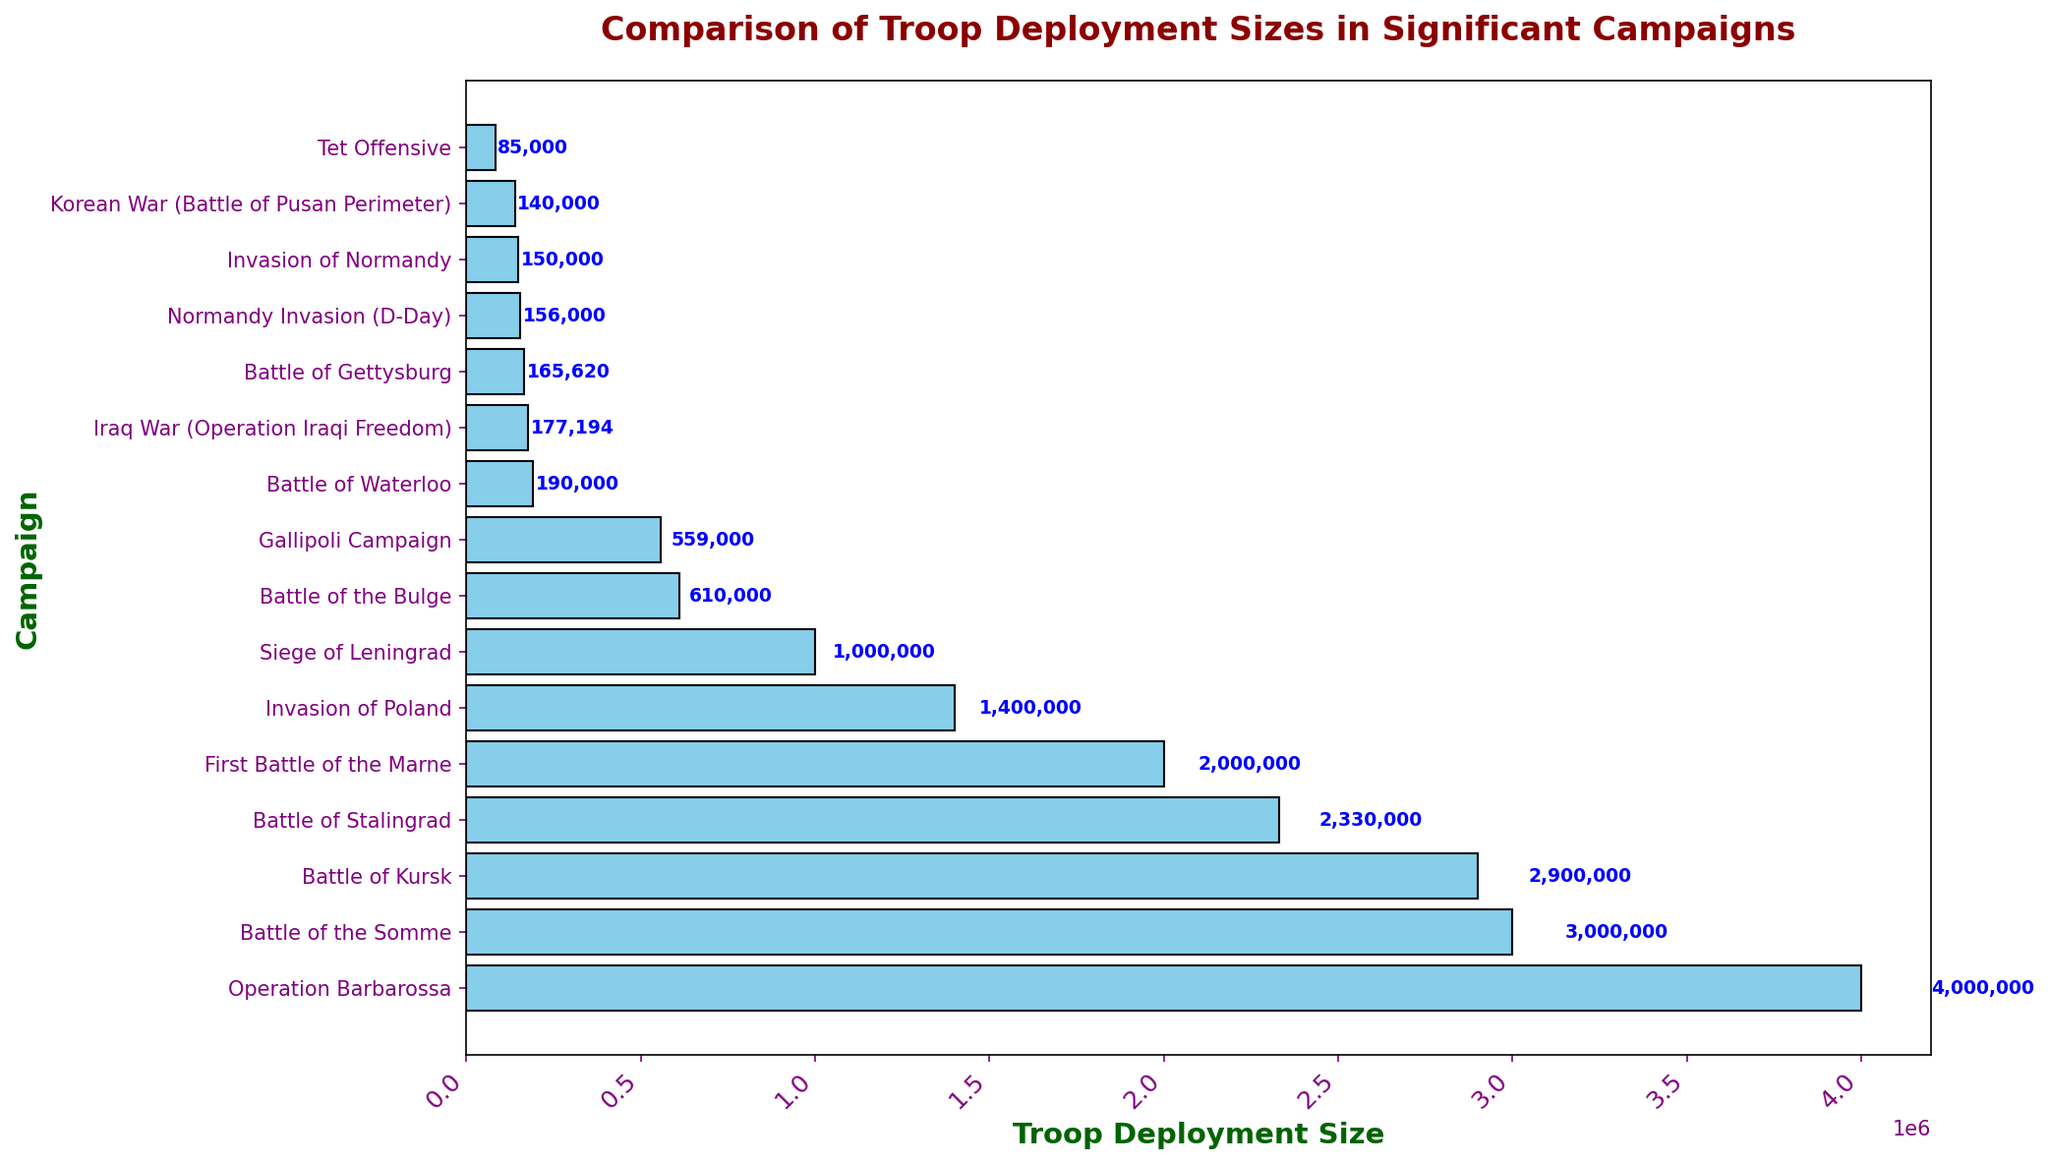What's the campaign with the highest troop deployment size? To understand which campaign had the highest troop deployment size, we identify the bar with the greatest length, representing the largest value. The 'Operation Barbarossa' bar is the highest.
Answer: Operation Barbarossa Which campaign had a larger troop deployment, the Battle of Stalingrad or the Battle of the Bulge? By comparing the lengths of the bars for the Battle of Stalingrad and the Battle of the Bulge, it is evident that the Battle of Stalingrad has a longer bar, indicating a larger troop deployment.
Answer: Battle of Stalingrad How does the troop deployment size for the Invasion of Poland compare to that of the Normandy Invasion (D-Day)? Observing the bar lengths for both the Invasion of Poland and the Normandy Invasion (D-Day), the Invasion of Poland has a significantly longer bar, indicating a larger troop deployment size than Normandy Invasion (D-Day).
Answer: Invasion of Poland What is the total troop deployment size for the First Battle of the Marne and the Battle of the Somme combined? To find the total, add the troop deployment sizes for the First Battle of the Marne (2,000,000) and the Battle of the Somme (3,000,000). The calculation is 2,000,000 + 3,000,000 = 5,000,000.
Answer: 5,000,000 Which campaign between the Gallipoli Campaign and the Invasion of Normandy had fewer troops deployed? Comparing the bars of the Gallipoli Campaign and the Invasion of Normandy, the Invasion of Normandy has a shorter bar, indicating fewer troops were deployed compared to the Gallipoli Campaign.
Answer: Invasion of Normandy What’s the average troop deployment size for the campaigns in the 20th century listed? Calculate the average by adding the troop deployment sizes for all 20th-century campaigns and dividing by the number of these campaigns. These are Battle of Kursk (2,900,000), Operation Barbarossa (4,000,000), Siege of Leningrad (1,000,000), Battle of Stalingrad (2,330,000), Battle of the Bulge (610,000), Invasion of Poland (1,400,000), First Battle of the Marne (2,000,000), Gallipoli Campaign (559,000), Battle of the Somme (3,000,000), Tet Offensive (85,000), and Korean War (Battle of Pusan Perimeter) (140,000). The calculation is (2,900,000 + 4,000,000 + 1,000,000 + 2,330,000 + 610,000 + 1,400,000 + 2,000,000 + 559,000 + 3,000,000 + 85,000 + 140,000) / 11 = 1,556,364.
Answer: 1,556,364 Which campaign had the smallest troop deployment size on the chart? Identifying the bar with the shortest length will indicate the campaign with the smallest troop deployment size, which is the Tet Offensive with 85,000 troops.
Answer: Tet Offensive 